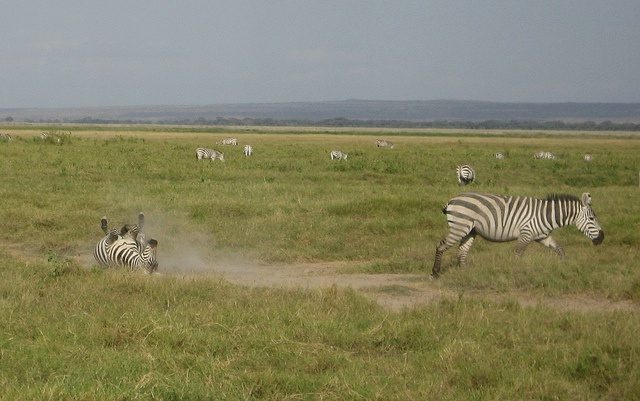Describe the objects in this image and their specific colors. I can see zebra in darkgray, gray, olive, and tan tones, zebra in darkgray, gray, and tan tones, zebra in darkgray, gray, and darkgreen tones, zebra in darkgray, gray, tan, and olive tones, and zebra in darkgray, gray, olive, and tan tones in this image. 